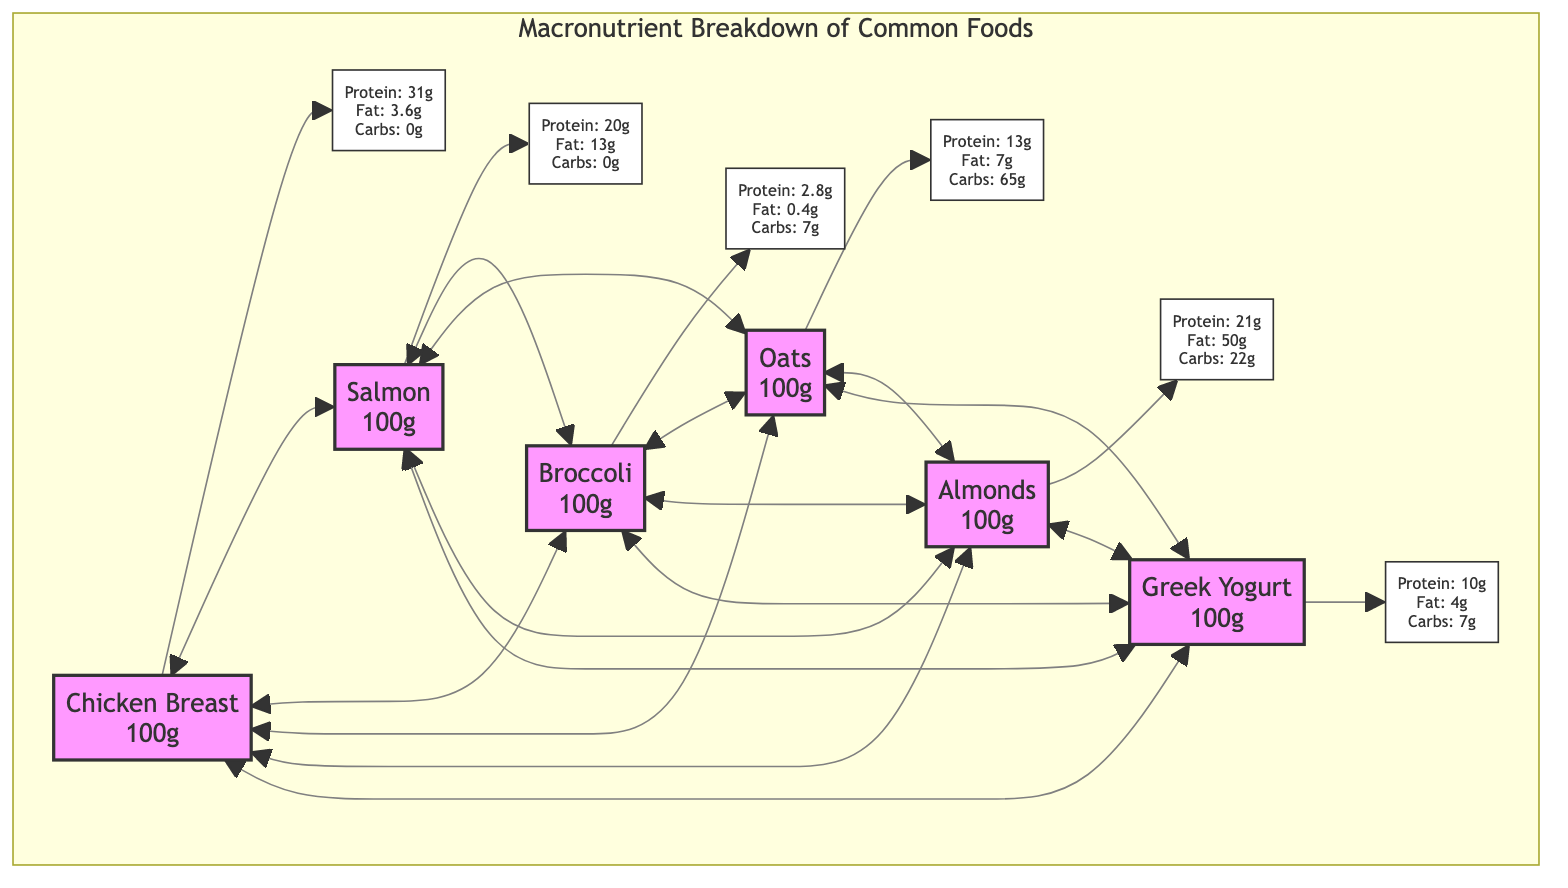What is the protein content of Chicken Breast per 100g? The diagram indicates that Chicken Breast has a protein content of 31 grams per 100 grams of the food.
Answer: 31g Which food contains the highest fat content? By comparing the fat values listed alongside each food, Almonds show the highest fat content at 50 grams per 100 grams.
Answer: 50g How many grams of carbohydrates are in Broccoli? The diagram denotes that Broccoli has 7 grams of carbohydrates for every 100 grams of the food.
Answer: 7g If you want a food high in protein and low in fat, which option should you choose? Looking at the protein and fat values, Chicken Breast provides 31 grams of protein and only 3.6 grams of fat, making it the best choice for high protein and low fat.
Answer: Chicken Breast Which two foods have the same carbohydrate content? The carbohydrate values for Greek Yogurt and Broccoli are both at 7 grams, hence they share the same amount of carbs.
Answer: Greek Yogurt and Broccoli What is the total number of foods displayed in the diagram? There are six food items illustrated in the Macronutrient Breakdown section of the diagram.
Answer: 6 Which food has a carbohydrate value closest to 0 grams? Among the listed foods, Chicken Breast has 0 grams of carbohydrates, thus it is the food with values closest to zero in that category.
Answer: Chicken Breast Which food has the lowest protein content? Upon examining the protein values, Broccoli has the least amount of protein at 2.8 grams per 100 grams.
Answer: Broccoli Are the protein and fat contents of Salmon higher than those of Chicken Breast? Salmon is listed with 20 grams of protein and 13 grams of fat while Chicken Breast has 31 grams of protein and 3.6 grams of fat, making Chicken Breast higher in protein and lower in fat.
Answer: No 